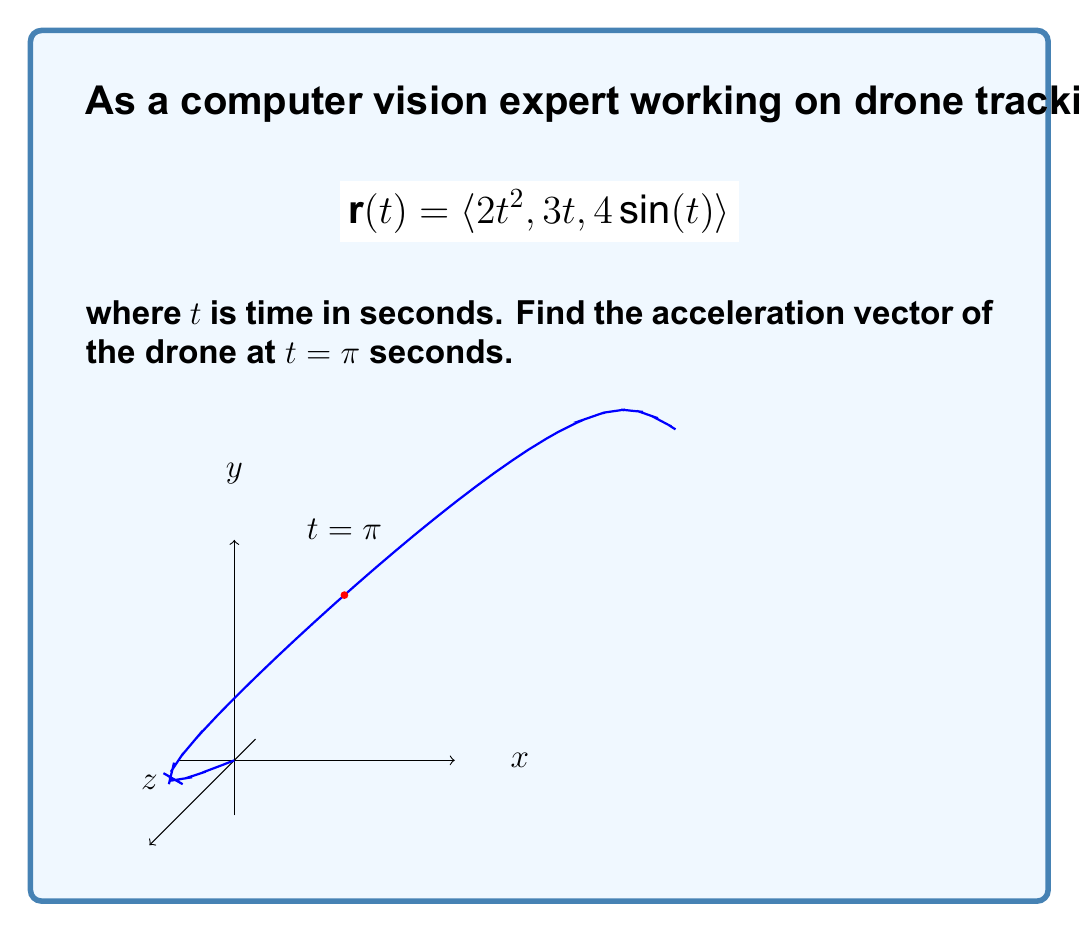Help me with this question. To find the acceleration vector, we need to differentiate the position vector twice with respect to time:

1) First, let's find the velocity vector by differentiating $\mathbf{r}(t)$:
   $$\mathbf{v}(t) = \frac{d}{dt}\mathbf{r}(t) = \langle 4t, 3, 4\cos(t) \rangle$$

2) Now, let's find the acceleration vector by differentiating $\mathbf{v}(t)$:
   $$\mathbf{a}(t) = \frac{d}{dt}\mathbf{v}(t) = \langle 4, 0, -4\sin(t) \rangle$$

3) We need to evaluate $\mathbf{a}(t)$ at $t = \pi$:
   $$\mathbf{a}(\pi) = \langle 4, 0, -4\sin(\pi) \rangle$$

4) Simplify:
   $$\mathbf{a}(\pi) = \langle 4, 0, 0 \rangle$$

Therefore, the acceleration vector of the drone at $t = \pi$ seconds is $\langle 4, 0, 0 \rangle$ m/s².
Answer: $\langle 4, 0, 0 \rangle$ m/s² 